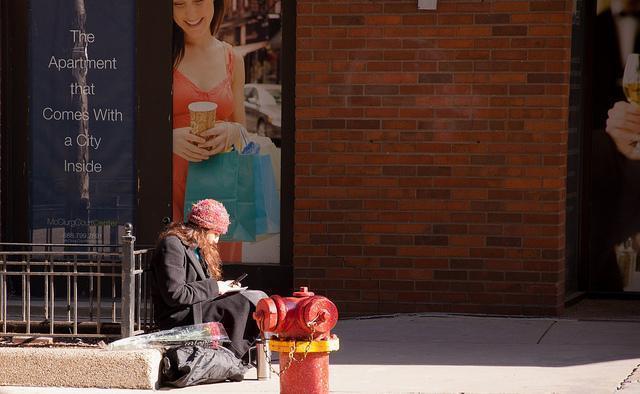What word most closely relates to the red and green things very close to the lady?
Indicate the correct response and explain using: 'Answer: answer
Rationale: rationale.'
Options: Romance, power, wealth, conflict. Answer: romance.
Rationale: The objects in question are roses based on their color and shape. roses are traditionally given on valentines day and other special romantic occasions. 